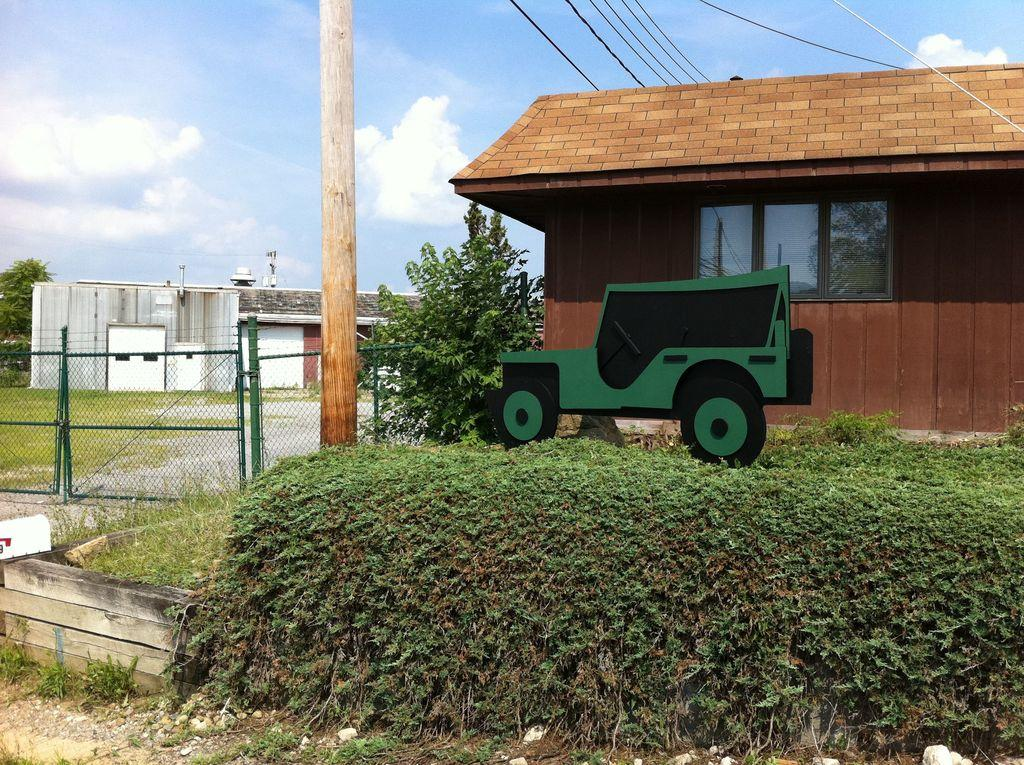What can be seen in the foreground of the picture? In the foreground of the picture, there are plants, a railing, a pole, and various objects. What is located in the middle of the picture? There are buildings in the middle of the picture. What can be seen at the top of the picture? At the top of the picture, there are cables and the sky is visible. How does the bomb explode in the picture? There is no bomb present in the picture, so it cannot explode. What type of lift can be seen in the picture? There is no lift present in the picture. 